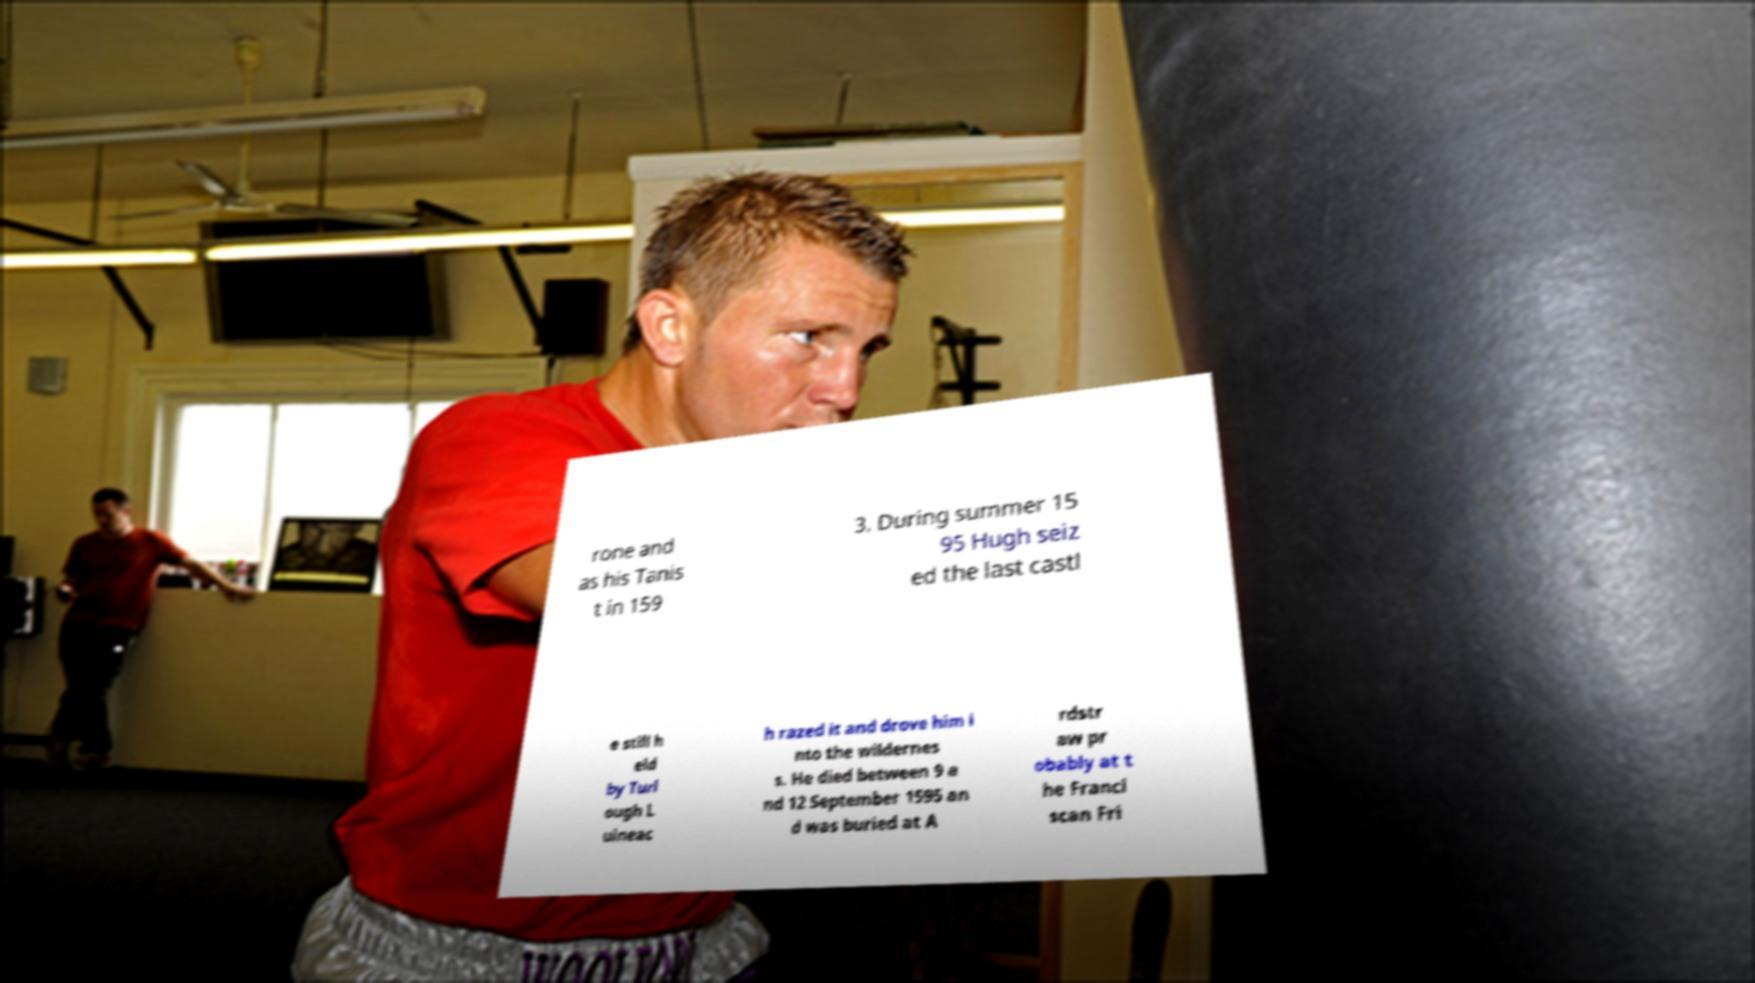Can you accurately transcribe the text from the provided image for me? rone and as his Tanis t in 159 3. During summer 15 95 Hugh seiz ed the last castl e still h eld by Turl ough L uineac h razed it and drove him i nto the wildernes s. He died between 9 a nd 12 September 1595 an d was buried at A rdstr aw pr obably at t he Franci scan Fri 